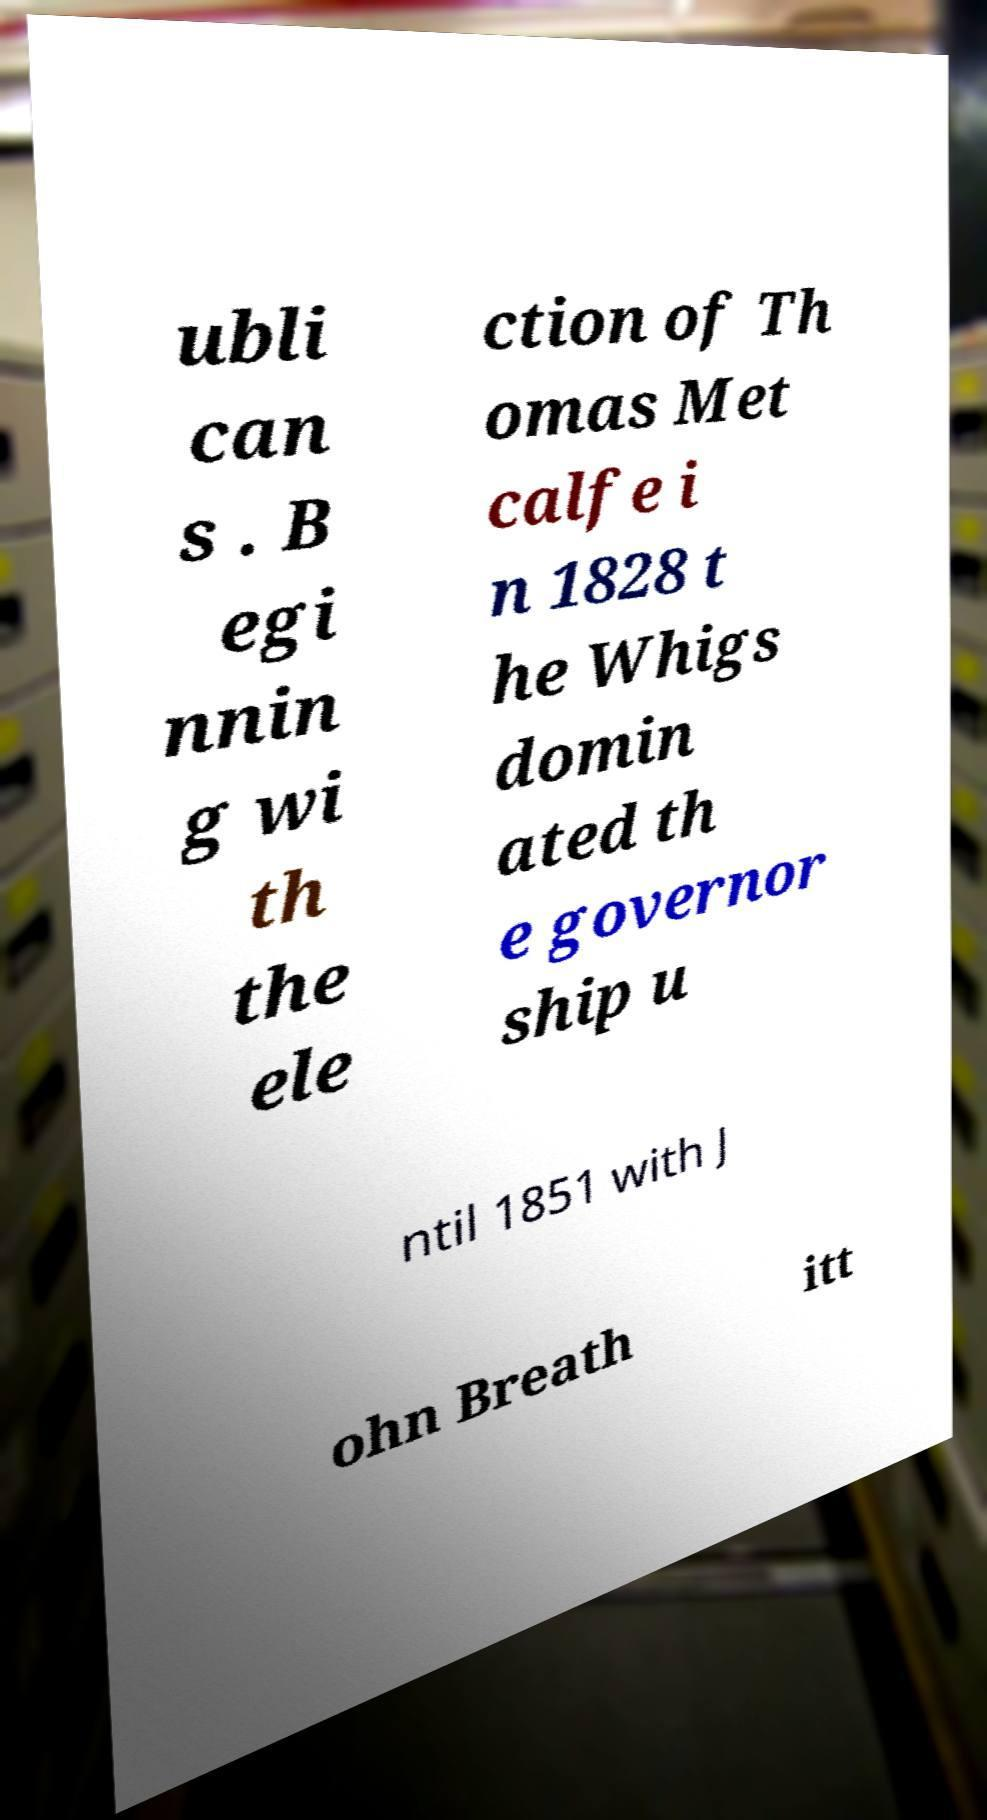Could you extract and type out the text from this image? ubli can s . B egi nnin g wi th the ele ction of Th omas Met calfe i n 1828 t he Whigs domin ated th e governor ship u ntil 1851 with J ohn Breath itt 